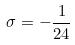<formula> <loc_0><loc_0><loc_500><loc_500>\sigma = - \frac { 1 } { 2 4 }</formula> 